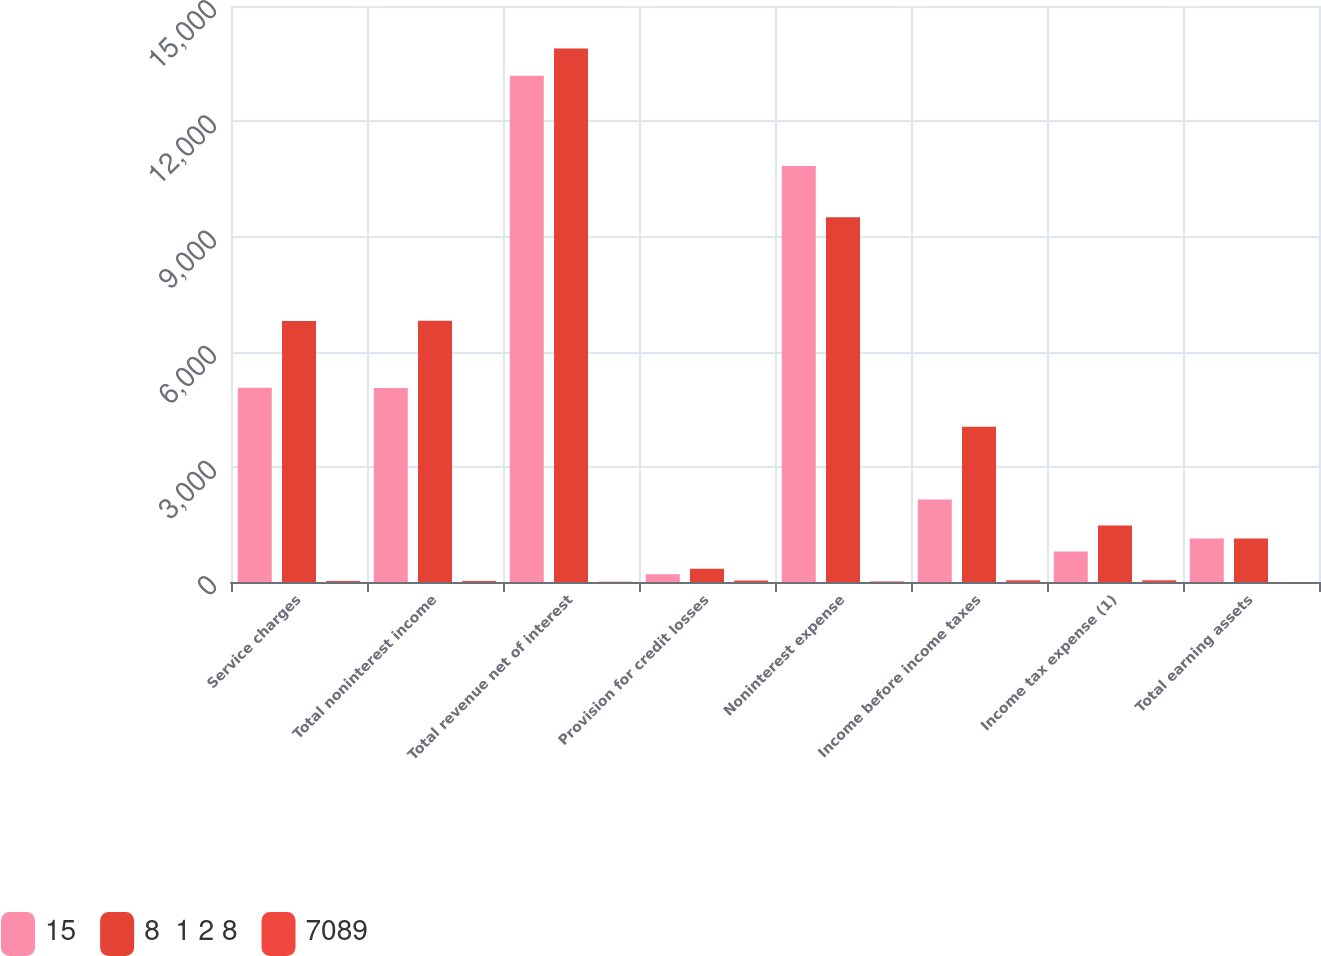Convert chart to OTSL. <chart><loc_0><loc_0><loc_500><loc_500><stacked_bar_chart><ecel><fcel>Service charges<fcel>Total noninterest income<fcel>Total revenue net of interest<fcel>Provision for credit losses<fcel>Noninterest expense<fcel>Income before income taxes<fcel>Income tax expense (1)<fcel>Total earning assets<nl><fcel>15<fcel>5058<fcel>5053<fcel>13181<fcel>201<fcel>10831<fcel>2149<fcel>797<fcel>1133.5<nl><fcel>8  1 2 8<fcel>6796<fcel>6801<fcel>13890<fcel>343<fcel>9501<fcel>4046<fcel>1470<fcel>1133.5<nl><fcel>7089<fcel>26<fcel>26<fcel>5<fcel>41<fcel>14<fcel>47<fcel>46<fcel>1<nl></chart> 